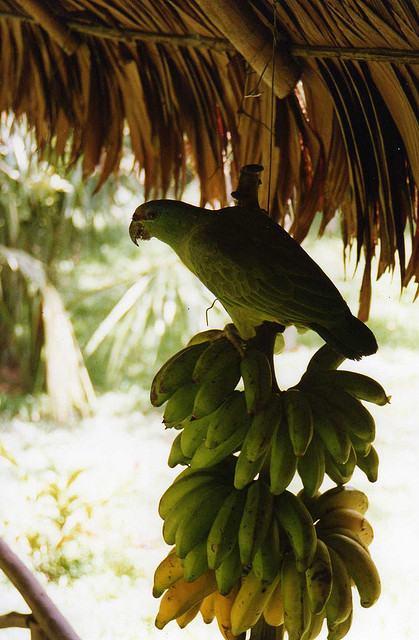<image>Does this type of bird eat bananas? It is ambiguous whether this type of bird eats bananas. The answer can be both yes and no. Does this type of bird eat bananas? I don't know if this type of bird eats bananas. It can eat both bananas and not eat bananas. 